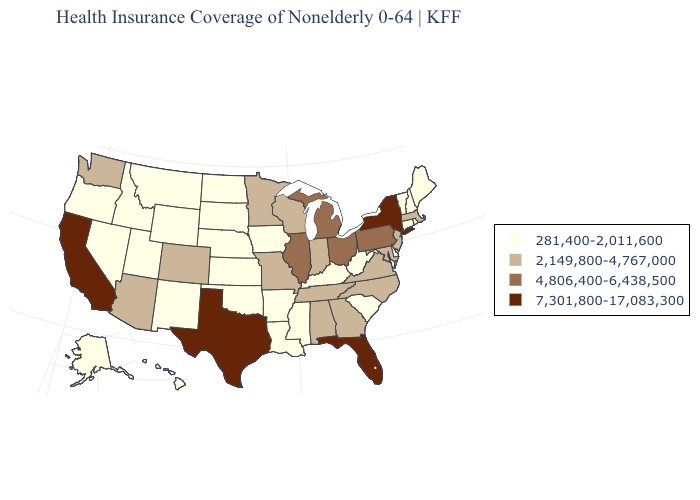Among the states that border Connecticut , does Rhode Island have the lowest value?
Write a very short answer. Yes. Which states have the lowest value in the South?
Write a very short answer. Arkansas, Delaware, Kentucky, Louisiana, Mississippi, Oklahoma, South Carolina, West Virginia. Does Florida have the highest value in the South?
Concise answer only. Yes. What is the value of New Mexico?
Keep it brief. 281,400-2,011,600. Which states have the highest value in the USA?
Short answer required. California, Florida, New York, Texas. Among the states that border Minnesota , which have the lowest value?
Concise answer only. Iowa, North Dakota, South Dakota. What is the lowest value in states that border Wyoming?
Give a very brief answer. 281,400-2,011,600. Does Iowa have the same value as California?
Short answer required. No. Does the map have missing data?
Quick response, please. No. Among the states that border Nebraska , does Kansas have the highest value?
Give a very brief answer. No. Which states have the highest value in the USA?
Keep it brief. California, Florida, New York, Texas. Name the states that have a value in the range 2,149,800-4,767,000?
Keep it brief. Alabama, Arizona, Colorado, Georgia, Indiana, Maryland, Massachusetts, Minnesota, Missouri, New Jersey, North Carolina, Tennessee, Virginia, Washington, Wisconsin. Among the states that border Mississippi , does Alabama have the highest value?
Keep it brief. Yes. Name the states that have a value in the range 4,806,400-6,438,500?
Write a very short answer. Illinois, Michigan, Ohio, Pennsylvania. 